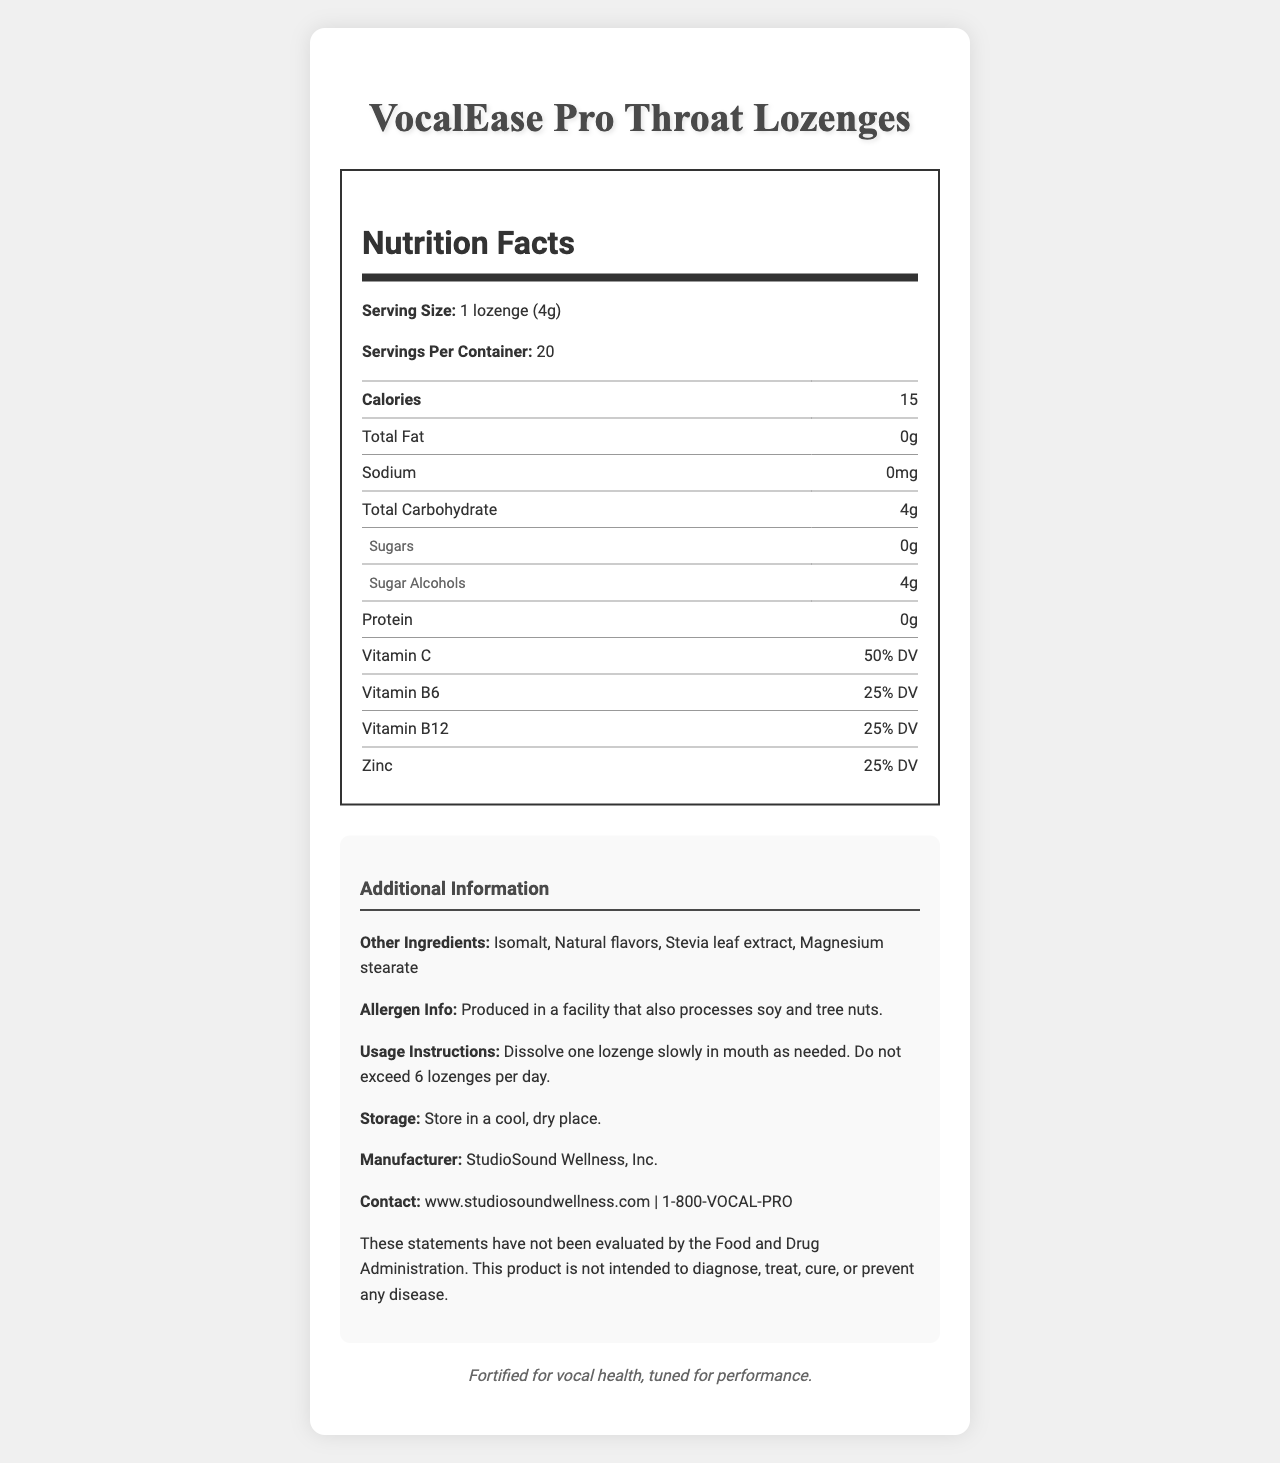what is the serving size? The serving size is mentioned as "1 lozenge (4g)" right at the beginning of the Nutrition Facts section.
Answer: 1 lozenge (4g) how many calories are in one serving? The Nutrition Facts table shows that there are 15 calories per serving.
Answer: 15 how much vitamin C is in each lozenge? The table lists that each lozenge contains 50% of the Daily Value (DV) of Vitamin C.
Answer: 50% DV which vitamins are included in the lozenges? The table shows the percentages of Daily Value for Vitamin C, Vitamin B6, and Vitamin B12.
Answer: Vitamin C, Vitamin B6, Vitamin B12 how should these lozenges be stored? The storage instructions state to store the lozenges in a cool, dry place.
Answer: Store in a cool, dry place. how many lozenges are in one container? The label mentions that there are 20 servings per container, and since the serving size is 1 lozenge, there are 20 lozenges in one container.
Answer: 20 who is the manufacturer of the lozenges? This information is provided in the additional information section as "Manufacturer: StudioSound Wellness, Inc."
Answer: StudioSound Wellness, Inc. which of the following ingredients is NOT one of the other ingredients? A. Isomalt B. Stevia leaf extract C. Menthol D. Honey Menthol and honey are listed separately as extracts, while Isomalt and Stevia leaf extract are part of "other ingredients."
Answer: C what is the main target audience for this product? A. Athletes B. Vocalists C. Children D. Elderly people The product is specifically designed for vocalists, as mentioned in the tagline "Fortified for vocal health, tuned for performance."
Answer: B is this product evaluated by the FDA? The disclaimer clearly states that the statements have not been evaluated by the Food and Drug Administration.
Answer: No what is the total amount of sugar in this product? The Nutrition Facts section shows that sugars are 0g.
Answer: 0g What is the purpose of this document? A detailed nutrition facts label is designed to help consumers understand what nutrients and ingredients are in the product, how it should be used, and who manufactures it. It also includes a disclaimer about FDA evaluation and allergen info.
Answer: The document provides detailed nutrition information about VocalEase Pro Throat Lozenges, including serving size, calories, ingredients, vitamins, usage instructions, and manufacturer details. what is the percentage of daily value for zinc? The table under vitamins and minerals shows that the percentage of daily value for zinc is 25%.
Answer: 25% DV can I find the price of this product in the document? The document does not provide any pricing information for the VocalEase Pro Throat Lozenges.
Answer: Not enough information 